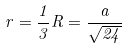Convert formula to latex. <formula><loc_0><loc_0><loc_500><loc_500>r = \frac { 1 } { 3 } R = \frac { a } { \sqrt { 2 4 } }</formula> 